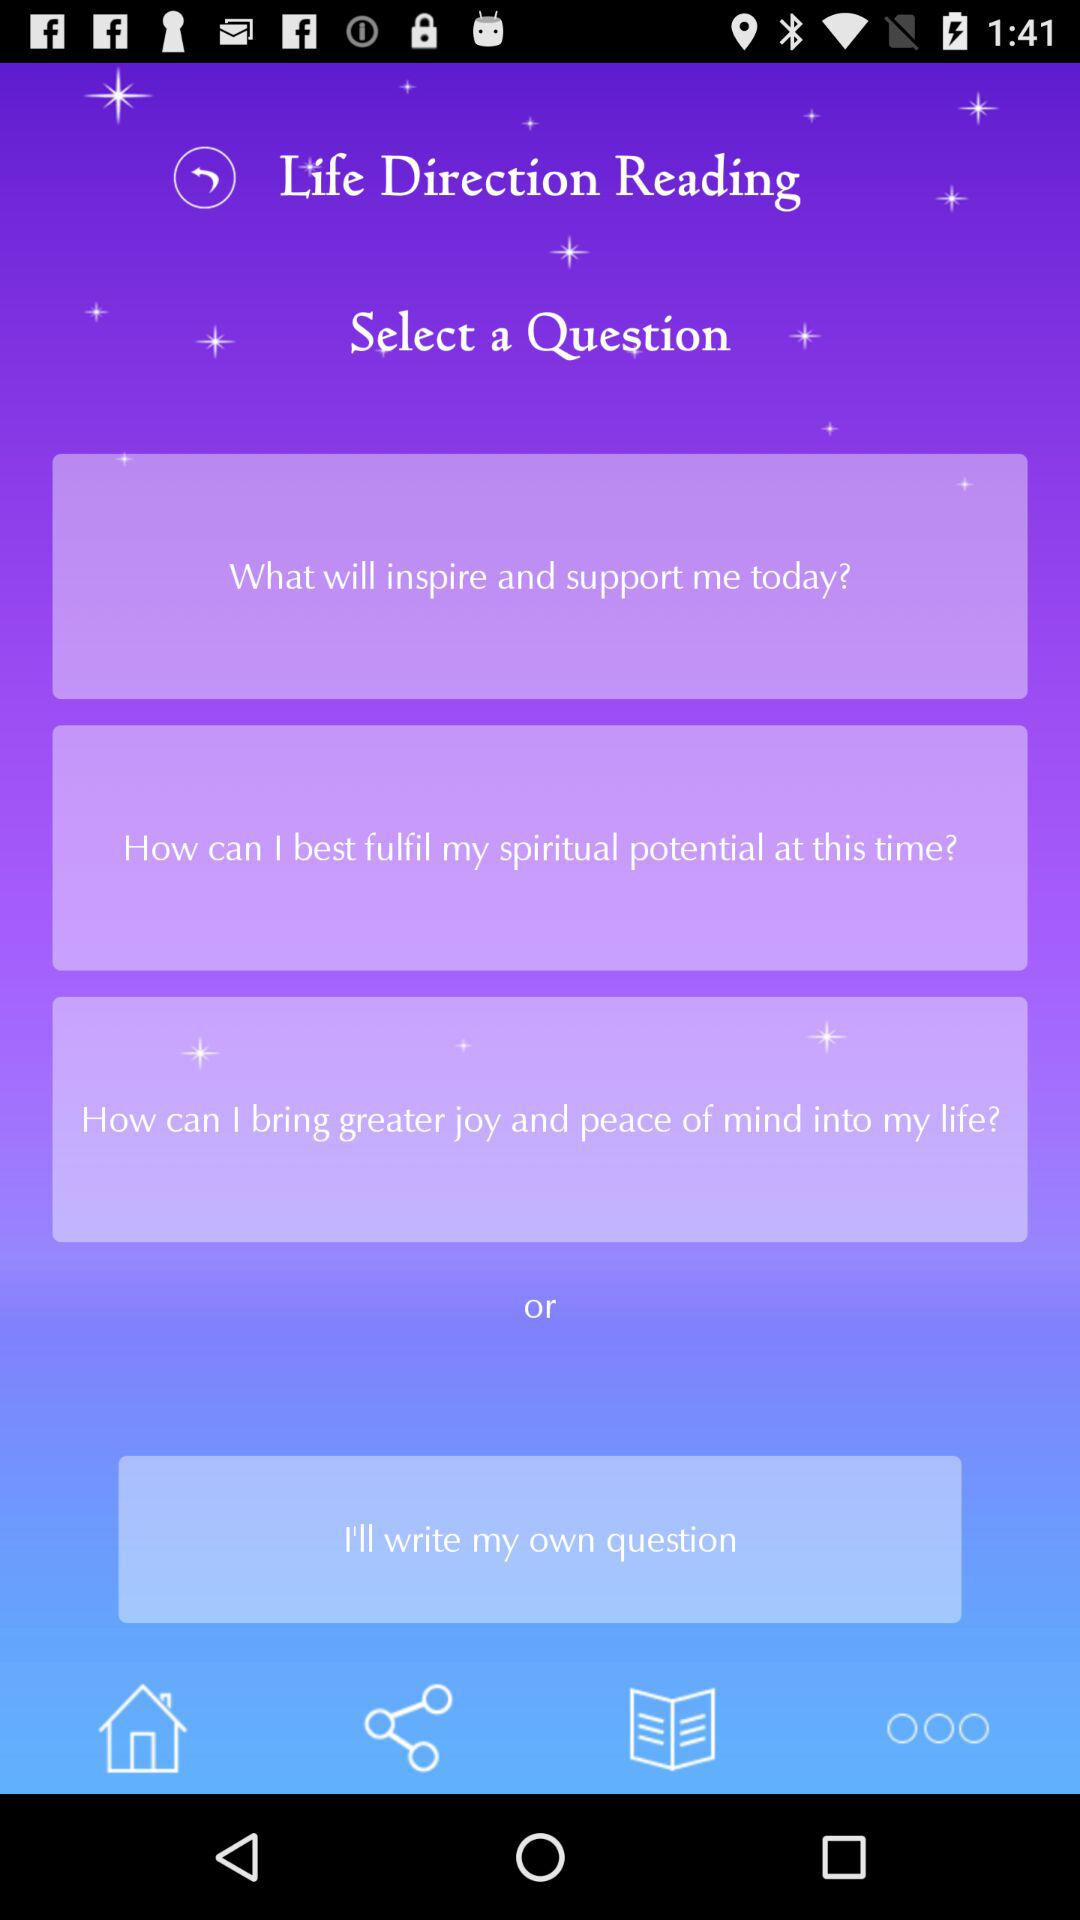How many question prompts are there?
Answer the question using a single word or phrase. 3 